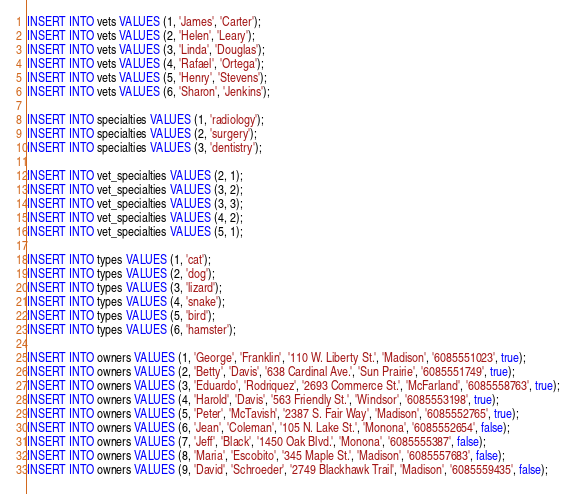Convert code to text. <code><loc_0><loc_0><loc_500><loc_500><_SQL_>INSERT INTO vets VALUES (1, 'James', 'Carter');
INSERT INTO vets VALUES (2, 'Helen', 'Leary');
INSERT INTO vets VALUES (3, 'Linda', 'Douglas');
INSERT INTO vets VALUES (4, 'Rafael', 'Ortega');
INSERT INTO vets VALUES (5, 'Henry', 'Stevens');
INSERT INTO vets VALUES (6, 'Sharon', 'Jenkins');

INSERT INTO specialties VALUES (1, 'radiology');
INSERT INTO specialties VALUES (2, 'surgery');
INSERT INTO specialties VALUES (3, 'dentistry');

INSERT INTO vet_specialties VALUES (2, 1);
INSERT INTO vet_specialties VALUES (3, 2);
INSERT INTO vet_specialties VALUES (3, 3);
INSERT INTO vet_specialties VALUES (4, 2);
INSERT INTO vet_specialties VALUES (5, 1);

INSERT INTO types VALUES (1, 'cat');
INSERT INTO types VALUES (2, 'dog');
INSERT INTO types VALUES (3, 'lizard');
INSERT INTO types VALUES (4, 'snake');
INSERT INTO types VALUES (5, 'bird');
INSERT INTO types VALUES (6, 'hamster');

INSERT INTO owners VALUES (1, 'George', 'Franklin', '110 W. Liberty St.', 'Madison', '6085551023', true);
INSERT INTO owners VALUES (2, 'Betty', 'Davis', '638 Cardinal Ave.', 'Sun Prairie', '6085551749', true);
INSERT INTO owners VALUES (3, 'Eduardo', 'Rodriquez', '2693 Commerce St.', 'McFarland', '6085558763', true);
INSERT INTO owners VALUES (4, 'Harold', 'Davis', '563 Friendly St.', 'Windsor', '6085553198', true);
INSERT INTO owners VALUES (5, 'Peter', 'McTavish', '2387 S. Fair Way', 'Madison', '6085552765', true);
INSERT INTO owners VALUES (6, 'Jean', 'Coleman', '105 N. Lake St.', 'Monona', '6085552654', false);
INSERT INTO owners VALUES (7, 'Jeff', 'Black', '1450 Oak Blvd.', 'Monona', '6085555387', false);
INSERT INTO owners VALUES (8, 'Maria', 'Escobito', '345 Maple St.', 'Madison', '6085557683', false);
INSERT INTO owners VALUES (9, 'David', 'Schroeder', '2749 Blackhawk Trail', 'Madison', '6085559435', false);</code> 